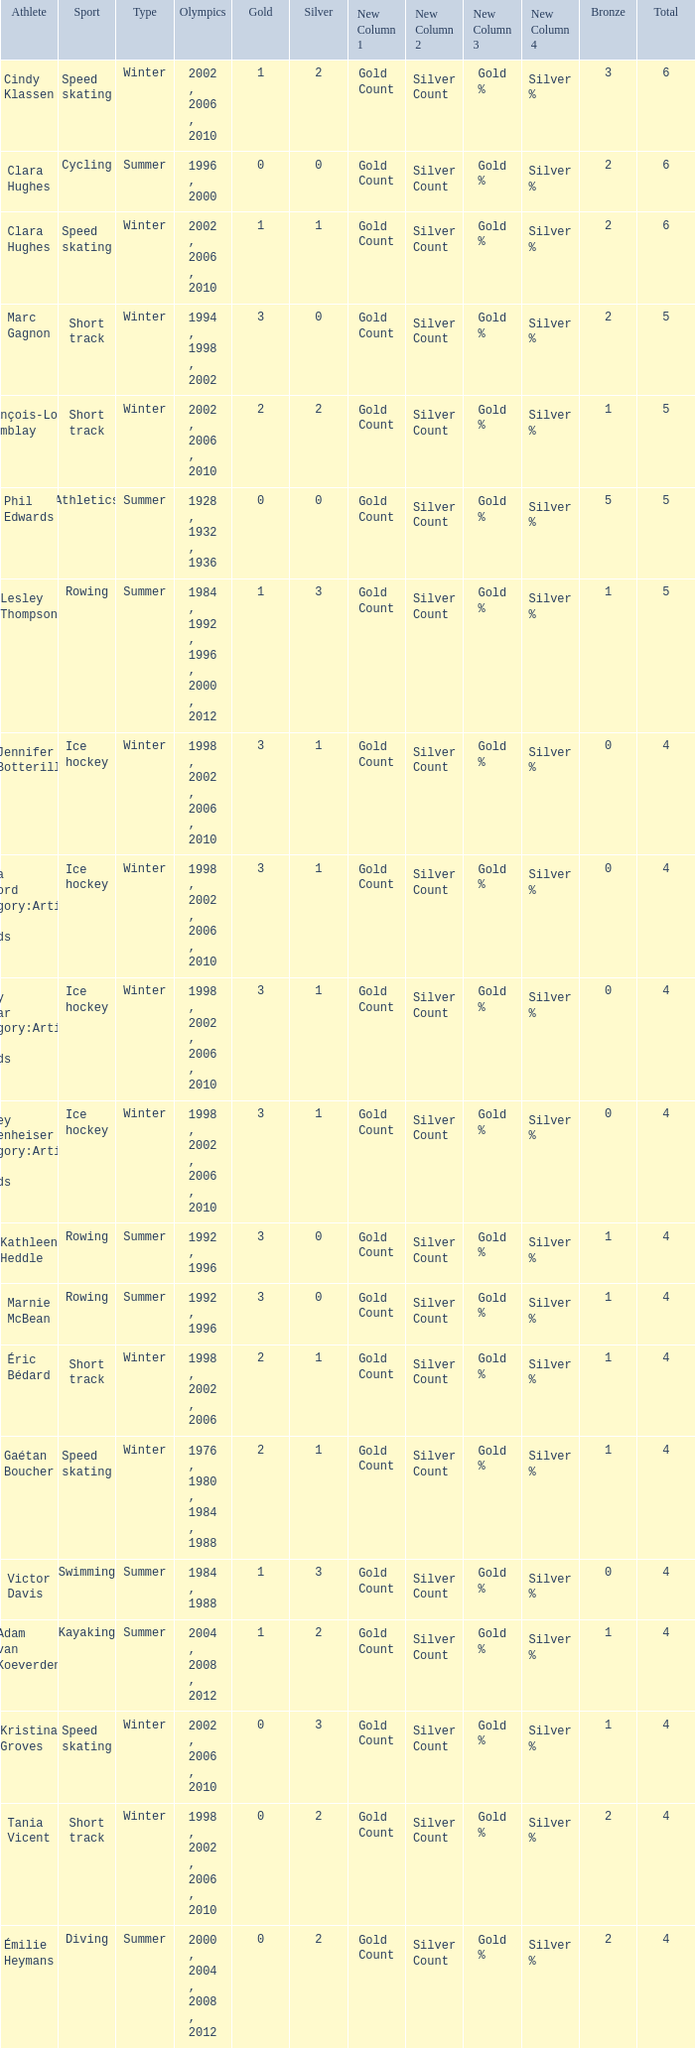What is the highest total medals winter athlete Clara Hughes has? 6.0. Write the full table. {'header': ['Athlete', 'Sport', 'Type', 'Olympics', 'Gold', 'Silver', 'New Column 1', 'New Column 2', 'New Column 3', 'New Column 4', 'Bronze', 'Total'], 'rows': [['Cindy Klassen', 'Speed skating', 'Winter', '2002 , 2006 , 2010', '1', '2', 'Gold Count', 'Silver Count', 'Gold %', 'Silver %', '3', '6'], ['Clara Hughes', 'Cycling', 'Summer', '1996 , 2000', '0', '0', 'Gold Count', 'Silver Count', 'Gold %', 'Silver %', '2', '6'], ['Clara Hughes', 'Speed skating', 'Winter', '2002 , 2006 , 2010', '1', '1', 'Gold Count', 'Silver Count', 'Gold %', 'Silver %', '2', '6'], ['Marc Gagnon', 'Short track', 'Winter', '1994 , 1998 , 2002', '3', '0', 'Gold Count', 'Silver Count', 'Gold %', 'Silver %', '2', '5'], ['François-Louis Tremblay', 'Short track', 'Winter', '2002 , 2006 , 2010', '2', '2', 'Gold Count', 'Silver Count', 'Gold %', 'Silver %', '1', '5'], ['Phil Edwards', 'Athletics', 'Summer', '1928 , 1932 , 1936', '0', '0', 'Gold Count', 'Silver Count', 'Gold %', 'Silver %', '5', '5'], ['Lesley Thompson', 'Rowing', 'Summer', '1984 , 1992 , 1996 , 2000 , 2012', '1', '3', 'Gold Count', 'Silver Count', 'Gold %', 'Silver %', '1', '5'], ['Jennifer Botterill', 'Ice hockey', 'Winter', '1998 , 2002 , 2006 , 2010', '3', '1', 'Gold Count', 'Silver Count', 'Gold %', 'Silver %', '0', '4'], ['Jayna Hefford Category:Articles with hCards', 'Ice hockey', 'Winter', '1998 , 2002 , 2006 , 2010', '3', '1', 'Gold Count', 'Silver Count', 'Gold %', 'Silver %', '0', '4'], ['Becky Kellar Category:Articles with hCards', 'Ice hockey', 'Winter', '1998 , 2002 , 2006 , 2010', '3', '1', 'Gold Count', 'Silver Count', 'Gold %', 'Silver %', '0', '4'], ['Hayley Wickenheiser Category:Articles with hCards', 'Ice hockey', 'Winter', '1998 , 2002 , 2006 , 2010', '3', '1', 'Gold Count', 'Silver Count', 'Gold %', 'Silver %', '0', '4'], ['Kathleen Heddle', 'Rowing', 'Summer', '1992 , 1996', '3', '0', 'Gold Count', 'Silver Count', 'Gold %', 'Silver %', '1', '4'], ['Marnie McBean', 'Rowing', 'Summer', '1992 , 1996', '3', '0', 'Gold Count', 'Silver Count', 'Gold %', 'Silver %', '1', '4'], ['Éric Bédard', 'Short track', 'Winter', '1998 , 2002 , 2006', '2', '1', 'Gold Count', 'Silver Count', 'Gold %', 'Silver %', '1', '4'], ['Gaétan Boucher', 'Speed skating', 'Winter', '1976 , 1980 , 1984 , 1988', '2', '1', 'Gold Count', 'Silver Count', 'Gold %', 'Silver %', '1', '4'], ['Victor Davis', 'Swimming', 'Summer', '1984 , 1988', '1', '3', 'Gold Count', 'Silver Count', 'Gold %', 'Silver %', '0', '4'], ['Adam van Koeverden', 'Kayaking', 'Summer', '2004 , 2008 , 2012', '1', '2', 'Gold Count', 'Silver Count', 'Gold %', 'Silver %', '1', '4'], ['Kristina Groves', 'Speed skating', 'Winter', '2002 , 2006 , 2010', '0', '3', 'Gold Count', 'Silver Count', 'Gold %', 'Silver %', '1', '4'], ['Tania Vicent', 'Short track', 'Winter', '1998 , 2002 , 2006 , 2010', '0', '2', 'Gold Count', 'Silver Count', 'Gold %', 'Silver %', '2', '4'], ['Émilie Heymans', 'Diving', 'Summer', '2000 , 2004 , 2008 , 2012', '0', '2', 'Gold Count', 'Silver Count', 'Gold %', 'Silver %', '2', '4']]} 